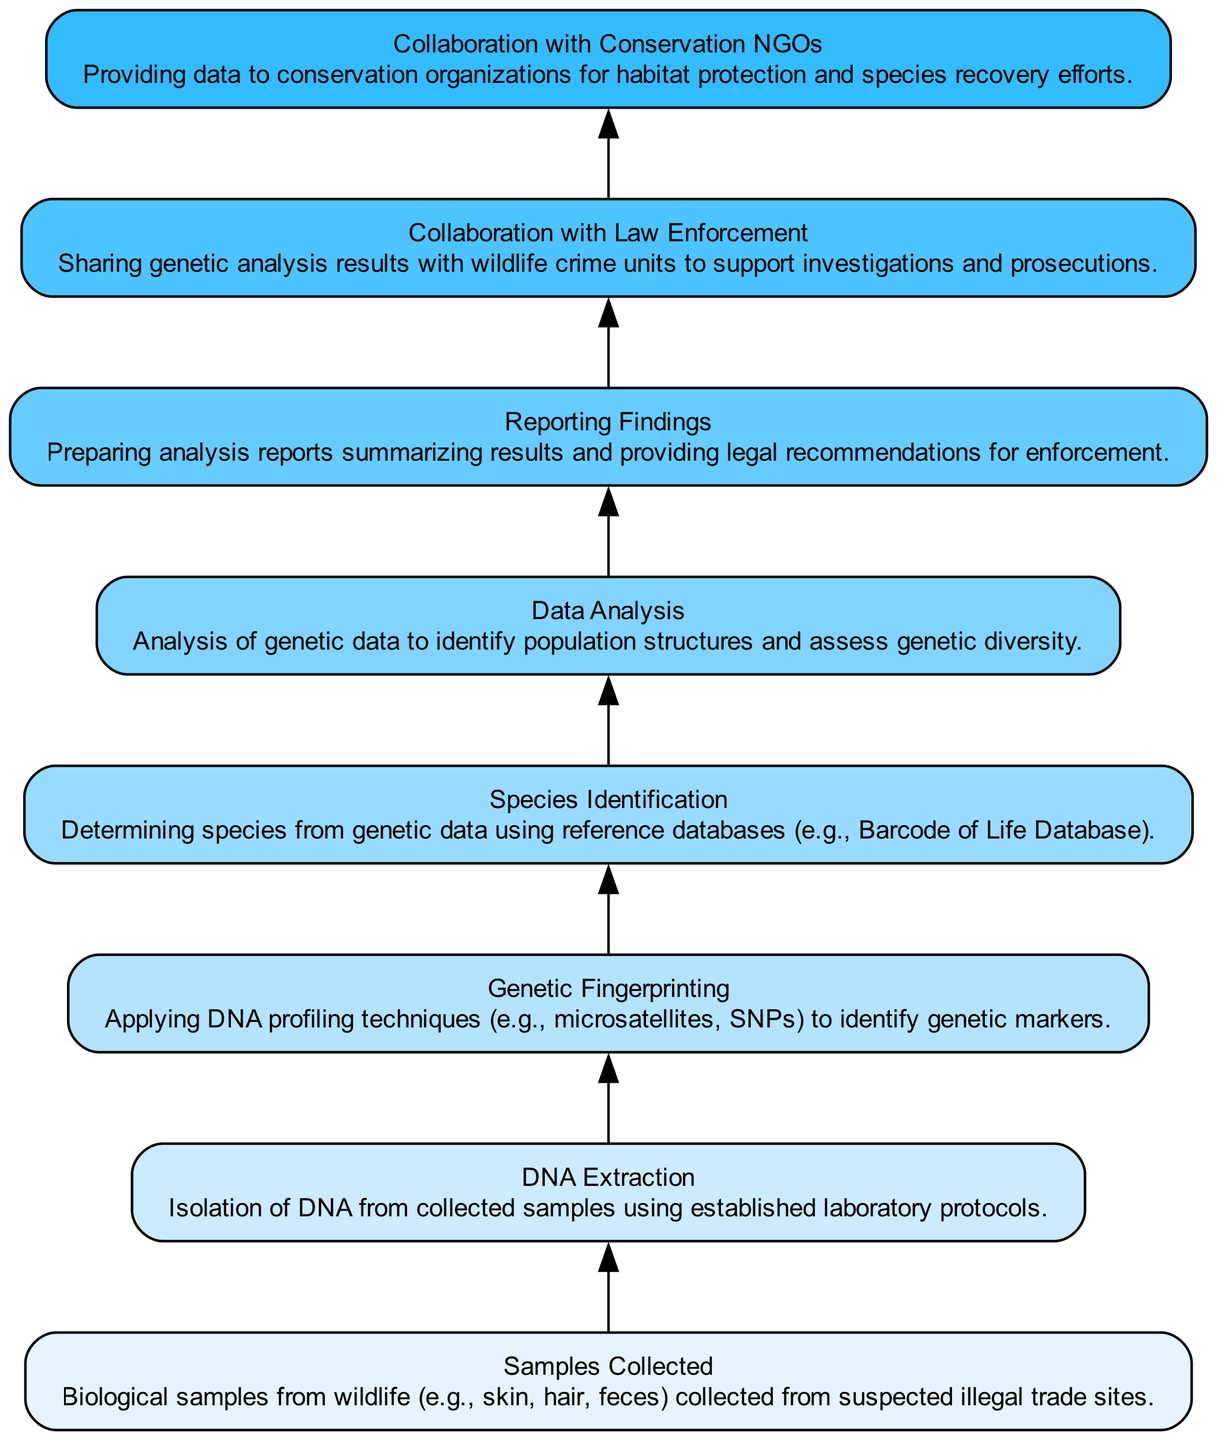What is the first step in the DNA analysis flow chart? The first step is "Samples Collected," where biological samples from wildlife are gathered from suspected illegal trade sites.
Answer: Samples Collected How many nodes are in the diagram? There are eight nodes representing distinct steps in the data flow of DNA analysis for law enforcement and conservation NGOs.
Answer: 8 What is the last step in the flow chart? The last step is "Collaboration with Conservation NGOs," where data is provided to conservation organizations for their efforts.
Answer: Collaboration with Conservation NGOs Which step involves analysis of genetic data? The step involving analysis of genetic data is "Data Analysis," where genetic data is analyzed to identify population structures and assess genetic diversity.
Answer: Data Analysis What is the relationship between "DNA Extraction" and "Genetic Fingerprinting"? "DNA Extraction" is a precursor step to "Genetic Fingerprinting," meaning DNA must be isolated before genetic profiling techniques can be applied.
Answer: Precursor How many collaborations are mentioned in the flow chart? There are two collaborations mentioned: one with Law Enforcement and another with Conservation NGOs.
Answer: 2 What step comes immediately after "Species Identification"? The step that comes immediately after "Species Identification" is "Data Analysis," where the genetic information is further analyzed.
Answer: Data Analysis What type of findings are reported after data analysis? The findings reported after data analysis are summarized in "Reporting Findings," which includes legal recommendations for enforcement.
Answer: Reporting Findings Which step helps support investigations and prosecutions? The step that helps support investigations and prosecutions is "Collaboration with Law Enforcement."
Answer: Collaboration with Law Enforcement 